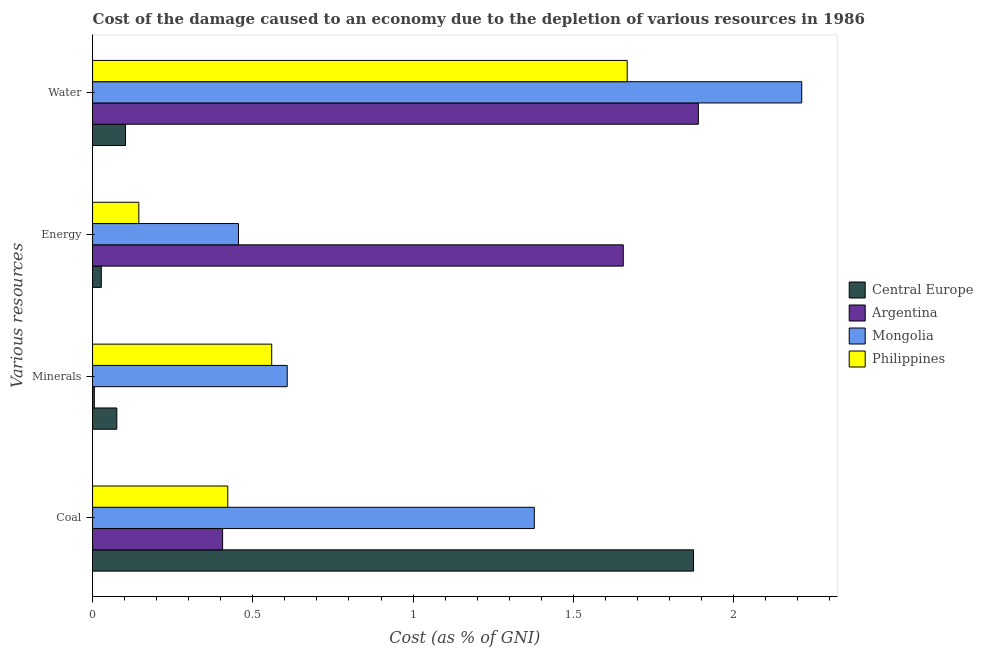How many different coloured bars are there?
Ensure brevity in your answer.  4. Are the number of bars on each tick of the Y-axis equal?
Ensure brevity in your answer.  Yes. What is the label of the 2nd group of bars from the top?
Provide a succinct answer. Energy. What is the cost of damage due to depletion of minerals in Philippines?
Provide a short and direct response. 0.56. Across all countries, what is the maximum cost of damage due to depletion of coal?
Your response must be concise. 1.88. Across all countries, what is the minimum cost of damage due to depletion of water?
Your response must be concise. 0.1. In which country was the cost of damage due to depletion of water maximum?
Your answer should be compact. Mongolia. In which country was the cost of damage due to depletion of coal minimum?
Provide a succinct answer. Argentina. What is the total cost of damage due to depletion of energy in the graph?
Offer a terse response. 2.28. What is the difference between the cost of damage due to depletion of water in Argentina and that in Mongolia?
Keep it short and to the point. -0.32. What is the difference between the cost of damage due to depletion of water in Philippines and the cost of damage due to depletion of coal in Mongolia?
Offer a very short reply. 0.29. What is the average cost of damage due to depletion of minerals per country?
Ensure brevity in your answer.  0.31. What is the difference between the cost of damage due to depletion of minerals and cost of damage due to depletion of energy in Argentina?
Keep it short and to the point. -1.65. What is the ratio of the cost of damage due to depletion of minerals in Philippines to that in Central Europe?
Your answer should be compact. 7.39. What is the difference between the highest and the second highest cost of damage due to depletion of energy?
Offer a very short reply. 1.2. What is the difference between the highest and the lowest cost of damage due to depletion of minerals?
Your answer should be very brief. 0.6. In how many countries, is the cost of damage due to depletion of coal greater than the average cost of damage due to depletion of coal taken over all countries?
Offer a very short reply. 2. Is it the case that in every country, the sum of the cost of damage due to depletion of coal and cost of damage due to depletion of minerals is greater than the sum of cost of damage due to depletion of energy and cost of damage due to depletion of water?
Your response must be concise. No. What does the 1st bar from the top in Water represents?
Give a very brief answer. Philippines. What does the 4th bar from the bottom in Energy represents?
Make the answer very short. Philippines. How many bars are there?
Offer a very short reply. 16. What is the difference between two consecutive major ticks on the X-axis?
Your answer should be very brief. 0.5. Are the values on the major ticks of X-axis written in scientific E-notation?
Keep it short and to the point. No. How many legend labels are there?
Provide a succinct answer. 4. What is the title of the graph?
Provide a succinct answer. Cost of the damage caused to an economy due to the depletion of various resources in 1986 . What is the label or title of the X-axis?
Offer a terse response. Cost (as % of GNI). What is the label or title of the Y-axis?
Provide a succinct answer. Various resources. What is the Cost (as % of GNI) in Central Europe in Coal?
Your answer should be compact. 1.88. What is the Cost (as % of GNI) of Argentina in Coal?
Keep it short and to the point. 0.41. What is the Cost (as % of GNI) of Mongolia in Coal?
Keep it short and to the point. 1.38. What is the Cost (as % of GNI) of Philippines in Coal?
Keep it short and to the point. 0.42. What is the Cost (as % of GNI) in Central Europe in Minerals?
Offer a terse response. 0.08. What is the Cost (as % of GNI) of Argentina in Minerals?
Offer a terse response. 0.01. What is the Cost (as % of GNI) in Mongolia in Minerals?
Keep it short and to the point. 0.61. What is the Cost (as % of GNI) in Philippines in Minerals?
Ensure brevity in your answer.  0.56. What is the Cost (as % of GNI) of Central Europe in Energy?
Ensure brevity in your answer.  0.03. What is the Cost (as % of GNI) in Argentina in Energy?
Keep it short and to the point. 1.66. What is the Cost (as % of GNI) of Mongolia in Energy?
Provide a short and direct response. 0.46. What is the Cost (as % of GNI) of Philippines in Energy?
Give a very brief answer. 0.14. What is the Cost (as % of GNI) of Central Europe in Water?
Keep it short and to the point. 0.1. What is the Cost (as % of GNI) in Argentina in Water?
Provide a short and direct response. 1.89. What is the Cost (as % of GNI) of Mongolia in Water?
Keep it short and to the point. 2.21. What is the Cost (as % of GNI) of Philippines in Water?
Make the answer very short. 1.67. Across all Various resources, what is the maximum Cost (as % of GNI) of Central Europe?
Ensure brevity in your answer.  1.88. Across all Various resources, what is the maximum Cost (as % of GNI) in Argentina?
Offer a terse response. 1.89. Across all Various resources, what is the maximum Cost (as % of GNI) in Mongolia?
Provide a succinct answer. 2.21. Across all Various resources, what is the maximum Cost (as % of GNI) in Philippines?
Your response must be concise. 1.67. Across all Various resources, what is the minimum Cost (as % of GNI) in Central Europe?
Your response must be concise. 0.03. Across all Various resources, what is the minimum Cost (as % of GNI) of Argentina?
Your response must be concise. 0.01. Across all Various resources, what is the minimum Cost (as % of GNI) in Mongolia?
Provide a succinct answer. 0.46. Across all Various resources, what is the minimum Cost (as % of GNI) of Philippines?
Offer a very short reply. 0.14. What is the total Cost (as % of GNI) in Central Europe in the graph?
Make the answer very short. 2.08. What is the total Cost (as % of GNI) in Argentina in the graph?
Provide a short and direct response. 3.96. What is the total Cost (as % of GNI) in Mongolia in the graph?
Provide a short and direct response. 4.65. What is the total Cost (as % of GNI) of Philippines in the graph?
Make the answer very short. 2.79. What is the difference between the Cost (as % of GNI) of Central Europe in Coal and that in Minerals?
Keep it short and to the point. 1.8. What is the difference between the Cost (as % of GNI) of Argentina in Coal and that in Minerals?
Make the answer very short. 0.4. What is the difference between the Cost (as % of GNI) of Mongolia in Coal and that in Minerals?
Offer a very short reply. 0.77. What is the difference between the Cost (as % of GNI) of Philippines in Coal and that in Minerals?
Your answer should be compact. -0.14. What is the difference between the Cost (as % of GNI) of Central Europe in Coal and that in Energy?
Provide a succinct answer. 1.85. What is the difference between the Cost (as % of GNI) of Argentina in Coal and that in Energy?
Your answer should be very brief. -1.25. What is the difference between the Cost (as % of GNI) of Philippines in Coal and that in Energy?
Your response must be concise. 0.28. What is the difference between the Cost (as % of GNI) in Central Europe in Coal and that in Water?
Offer a very short reply. 1.77. What is the difference between the Cost (as % of GNI) in Argentina in Coal and that in Water?
Provide a short and direct response. -1.48. What is the difference between the Cost (as % of GNI) of Mongolia in Coal and that in Water?
Your answer should be very brief. -0.83. What is the difference between the Cost (as % of GNI) of Philippines in Coal and that in Water?
Offer a very short reply. -1.25. What is the difference between the Cost (as % of GNI) of Central Europe in Minerals and that in Energy?
Ensure brevity in your answer.  0.05. What is the difference between the Cost (as % of GNI) in Argentina in Minerals and that in Energy?
Provide a succinct answer. -1.65. What is the difference between the Cost (as % of GNI) of Mongolia in Minerals and that in Energy?
Provide a succinct answer. 0.15. What is the difference between the Cost (as % of GNI) in Philippines in Minerals and that in Energy?
Keep it short and to the point. 0.41. What is the difference between the Cost (as % of GNI) in Central Europe in Minerals and that in Water?
Your answer should be compact. -0.03. What is the difference between the Cost (as % of GNI) of Argentina in Minerals and that in Water?
Make the answer very short. -1.88. What is the difference between the Cost (as % of GNI) in Mongolia in Minerals and that in Water?
Your answer should be compact. -1.61. What is the difference between the Cost (as % of GNI) in Philippines in Minerals and that in Water?
Make the answer very short. -1.11. What is the difference between the Cost (as % of GNI) in Central Europe in Energy and that in Water?
Offer a terse response. -0.08. What is the difference between the Cost (as % of GNI) in Argentina in Energy and that in Water?
Give a very brief answer. -0.23. What is the difference between the Cost (as % of GNI) of Mongolia in Energy and that in Water?
Your response must be concise. -1.76. What is the difference between the Cost (as % of GNI) in Philippines in Energy and that in Water?
Give a very brief answer. -1.52. What is the difference between the Cost (as % of GNI) in Central Europe in Coal and the Cost (as % of GNI) in Argentina in Minerals?
Offer a very short reply. 1.87. What is the difference between the Cost (as % of GNI) in Central Europe in Coal and the Cost (as % of GNI) in Mongolia in Minerals?
Give a very brief answer. 1.27. What is the difference between the Cost (as % of GNI) of Central Europe in Coal and the Cost (as % of GNI) of Philippines in Minerals?
Offer a very short reply. 1.32. What is the difference between the Cost (as % of GNI) of Argentina in Coal and the Cost (as % of GNI) of Mongolia in Minerals?
Keep it short and to the point. -0.2. What is the difference between the Cost (as % of GNI) of Argentina in Coal and the Cost (as % of GNI) of Philippines in Minerals?
Your answer should be compact. -0.15. What is the difference between the Cost (as % of GNI) in Mongolia in Coal and the Cost (as % of GNI) in Philippines in Minerals?
Keep it short and to the point. 0.82. What is the difference between the Cost (as % of GNI) in Central Europe in Coal and the Cost (as % of GNI) in Argentina in Energy?
Give a very brief answer. 0.22. What is the difference between the Cost (as % of GNI) of Central Europe in Coal and the Cost (as % of GNI) of Mongolia in Energy?
Make the answer very short. 1.42. What is the difference between the Cost (as % of GNI) of Central Europe in Coal and the Cost (as % of GNI) of Philippines in Energy?
Give a very brief answer. 1.73. What is the difference between the Cost (as % of GNI) of Argentina in Coal and the Cost (as % of GNI) of Mongolia in Energy?
Your answer should be very brief. -0.05. What is the difference between the Cost (as % of GNI) of Argentina in Coal and the Cost (as % of GNI) of Philippines in Energy?
Ensure brevity in your answer.  0.26. What is the difference between the Cost (as % of GNI) in Mongolia in Coal and the Cost (as % of GNI) in Philippines in Energy?
Keep it short and to the point. 1.23. What is the difference between the Cost (as % of GNI) of Central Europe in Coal and the Cost (as % of GNI) of Argentina in Water?
Provide a short and direct response. -0.01. What is the difference between the Cost (as % of GNI) of Central Europe in Coal and the Cost (as % of GNI) of Mongolia in Water?
Keep it short and to the point. -0.34. What is the difference between the Cost (as % of GNI) of Central Europe in Coal and the Cost (as % of GNI) of Philippines in Water?
Give a very brief answer. 0.21. What is the difference between the Cost (as % of GNI) in Argentina in Coal and the Cost (as % of GNI) in Mongolia in Water?
Offer a terse response. -1.81. What is the difference between the Cost (as % of GNI) in Argentina in Coal and the Cost (as % of GNI) in Philippines in Water?
Your answer should be compact. -1.26. What is the difference between the Cost (as % of GNI) in Mongolia in Coal and the Cost (as % of GNI) in Philippines in Water?
Provide a succinct answer. -0.29. What is the difference between the Cost (as % of GNI) in Central Europe in Minerals and the Cost (as % of GNI) in Argentina in Energy?
Offer a terse response. -1.58. What is the difference between the Cost (as % of GNI) of Central Europe in Minerals and the Cost (as % of GNI) of Mongolia in Energy?
Provide a succinct answer. -0.38. What is the difference between the Cost (as % of GNI) in Central Europe in Minerals and the Cost (as % of GNI) in Philippines in Energy?
Make the answer very short. -0.07. What is the difference between the Cost (as % of GNI) in Argentina in Minerals and the Cost (as % of GNI) in Mongolia in Energy?
Offer a very short reply. -0.45. What is the difference between the Cost (as % of GNI) of Argentina in Minerals and the Cost (as % of GNI) of Philippines in Energy?
Offer a terse response. -0.14. What is the difference between the Cost (as % of GNI) in Mongolia in Minerals and the Cost (as % of GNI) in Philippines in Energy?
Make the answer very short. 0.46. What is the difference between the Cost (as % of GNI) in Central Europe in Minerals and the Cost (as % of GNI) in Argentina in Water?
Your answer should be very brief. -1.81. What is the difference between the Cost (as % of GNI) in Central Europe in Minerals and the Cost (as % of GNI) in Mongolia in Water?
Provide a short and direct response. -2.14. What is the difference between the Cost (as % of GNI) in Central Europe in Minerals and the Cost (as % of GNI) in Philippines in Water?
Offer a very short reply. -1.59. What is the difference between the Cost (as % of GNI) of Argentina in Minerals and the Cost (as % of GNI) of Mongolia in Water?
Ensure brevity in your answer.  -2.21. What is the difference between the Cost (as % of GNI) in Argentina in Minerals and the Cost (as % of GNI) in Philippines in Water?
Your response must be concise. -1.66. What is the difference between the Cost (as % of GNI) of Mongolia in Minerals and the Cost (as % of GNI) of Philippines in Water?
Ensure brevity in your answer.  -1.06. What is the difference between the Cost (as % of GNI) of Central Europe in Energy and the Cost (as % of GNI) of Argentina in Water?
Offer a very short reply. -1.86. What is the difference between the Cost (as % of GNI) in Central Europe in Energy and the Cost (as % of GNI) in Mongolia in Water?
Make the answer very short. -2.19. What is the difference between the Cost (as % of GNI) in Central Europe in Energy and the Cost (as % of GNI) in Philippines in Water?
Provide a succinct answer. -1.64. What is the difference between the Cost (as % of GNI) in Argentina in Energy and the Cost (as % of GNI) in Mongolia in Water?
Provide a succinct answer. -0.56. What is the difference between the Cost (as % of GNI) in Argentina in Energy and the Cost (as % of GNI) in Philippines in Water?
Your answer should be compact. -0.01. What is the difference between the Cost (as % of GNI) of Mongolia in Energy and the Cost (as % of GNI) of Philippines in Water?
Provide a short and direct response. -1.21. What is the average Cost (as % of GNI) of Central Europe per Various resources?
Provide a short and direct response. 0.52. What is the average Cost (as % of GNI) of Argentina per Various resources?
Keep it short and to the point. 0.99. What is the average Cost (as % of GNI) in Mongolia per Various resources?
Offer a very short reply. 1.16. What is the average Cost (as % of GNI) in Philippines per Various resources?
Provide a short and direct response. 0.7. What is the difference between the Cost (as % of GNI) of Central Europe and Cost (as % of GNI) of Argentina in Coal?
Your answer should be compact. 1.47. What is the difference between the Cost (as % of GNI) of Central Europe and Cost (as % of GNI) of Mongolia in Coal?
Provide a short and direct response. 0.5. What is the difference between the Cost (as % of GNI) of Central Europe and Cost (as % of GNI) of Philippines in Coal?
Provide a short and direct response. 1.45. What is the difference between the Cost (as % of GNI) in Argentina and Cost (as % of GNI) in Mongolia in Coal?
Give a very brief answer. -0.97. What is the difference between the Cost (as % of GNI) in Argentina and Cost (as % of GNI) in Philippines in Coal?
Provide a succinct answer. -0.02. What is the difference between the Cost (as % of GNI) in Mongolia and Cost (as % of GNI) in Philippines in Coal?
Make the answer very short. 0.96. What is the difference between the Cost (as % of GNI) of Central Europe and Cost (as % of GNI) of Argentina in Minerals?
Keep it short and to the point. 0.07. What is the difference between the Cost (as % of GNI) in Central Europe and Cost (as % of GNI) in Mongolia in Minerals?
Offer a terse response. -0.53. What is the difference between the Cost (as % of GNI) of Central Europe and Cost (as % of GNI) of Philippines in Minerals?
Your response must be concise. -0.48. What is the difference between the Cost (as % of GNI) in Argentina and Cost (as % of GNI) in Mongolia in Minerals?
Your answer should be compact. -0.6. What is the difference between the Cost (as % of GNI) in Argentina and Cost (as % of GNI) in Philippines in Minerals?
Offer a terse response. -0.55. What is the difference between the Cost (as % of GNI) in Mongolia and Cost (as % of GNI) in Philippines in Minerals?
Make the answer very short. 0.05. What is the difference between the Cost (as % of GNI) in Central Europe and Cost (as % of GNI) in Argentina in Energy?
Offer a very short reply. -1.63. What is the difference between the Cost (as % of GNI) of Central Europe and Cost (as % of GNI) of Mongolia in Energy?
Your response must be concise. -0.43. What is the difference between the Cost (as % of GNI) in Central Europe and Cost (as % of GNI) in Philippines in Energy?
Offer a very short reply. -0.12. What is the difference between the Cost (as % of GNI) of Argentina and Cost (as % of GNI) of Mongolia in Energy?
Keep it short and to the point. 1.2. What is the difference between the Cost (as % of GNI) of Argentina and Cost (as % of GNI) of Philippines in Energy?
Keep it short and to the point. 1.51. What is the difference between the Cost (as % of GNI) in Mongolia and Cost (as % of GNI) in Philippines in Energy?
Provide a succinct answer. 0.31. What is the difference between the Cost (as % of GNI) of Central Europe and Cost (as % of GNI) of Argentina in Water?
Give a very brief answer. -1.79. What is the difference between the Cost (as % of GNI) in Central Europe and Cost (as % of GNI) in Mongolia in Water?
Give a very brief answer. -2.11. What is the difference between the Cost (as % of GNI) of Central Europe and Cost (as % of GNI) of Philippines in Water?
Ensure brevity in your answer.  -1.57. What is the difference between the Cost (as % of GNI) in Argentina and Cost (as % of GNI) in Mongolia in Water?
Your response must be concise. -0.32. What is the difference between the Cost (as % of GNI) of Argentina and Cost (as % of GNI) of Philippines in Water?
Offer a very short reply. 0.22. What is the difference between the Cost (as % of GNI) of Mongolia and Cost (as % of GNI) of Philippines in Water?
Your answer should be compact. 0.54. What is the ratio of the Cost (as % of GNI) of Central Europe in Coal to that in Minerals?
Give a very brief answer. 24.79. What is the ratio of the Cost (as % of GNI) of Argentina in Coal to that in Minerals?
Your answer should be very brief. 73.12. What is the ratio of the Cost (as % of GNI) in Mongolia in Coal to that in Minerals?
Your answer should be very brief. 2.27. What is the ratio of the Cost (as % of GNI) in Philippines in Coal to that in Minerals?
Your answer should be very brief. 0.75. What is the ratio of the Cost (as % of GNI) in Central Europe in Coal to that in Energy?
Your response must be concise. 68.76. What is the ratio of the Cost (as % of GNI) in Argentina in Coal to that in Energy?
Offer a terse response. 0.24. What is the ratio of the Cost (as % of GNI) in Mongolia in Coal to that in Energy?
Ensure brevity in your answer.  3.03. What is the ratio of the Cost (as % of GNI) of Philippines in Coal to that in Energy?
Make the answer very short. 2.92. What is the ratio of the Cost (as % of GNI) in Central Europe in Coal to that in Water?
Provide a short and direct response. 18.22. What is the ratio of the Cost (as % of GNI) in Argentina in Coal to that in Water?
Offer a terse response. 0.21. What is the ratio of the Cost (as % of GNI) of Mongolia in Coal to that in Water?
Offer a terse response. 0.62. What is the ratio of the Cost (as % of GNI) of Philippines in Coal to that in Water?
Your answer should be very brief. 0.25. What is the ratio of the Cost (as % of GNI) of Central Europe in Minerals to that in Energy?
Keep it short and to the point. 2.77. What is the ratio of the Cost (as % of GNI) in Argentina in Minerals to that in Energy?
Your answer should be compact. 0. What is the ratio of the Cost (as % of GNI) in Mongolia in Minerals to that in Energy?
Give a very brief answer. 1.33. What is the ratio of the Cost (as % of GNI) of Philippines in Minerals to that in Energy?
Provide a short and direct response. 3.87. What is the ratio of the Cost (as % of GNI) of Central Europe in Minerals to that in Water?
Your response must be concise. 0.73. What is the ratio of the Cost (as % of GNI) of Argentina in Minerals to that in Water?
Your response must be concise. 0. What is the ratio of the Cost (as % of GNI) of Mongolia in Minerals to that in Water?
Provide a succinct answer. 0.27. What is the ratio of the Cost (as % of GNI) of Philippines in Minerals to that in Water?
Your answer should be compact. 0.34. What is the ratio of the Cost (as % of GNI) in Central Europe in Energy to that in Water?
Your answer should be very brief. 0.27. What is the ratio of the Cost (as % of GNI) in Argentina in Energy to that in Water?
Give a very brief answer. 0.88. What is the ratio of the Cost (as % of GNI) in Mongolia in Energy to that in Water?
Make the answer very short. 0.21. What is the ratio of the Cost (as % of GNI) of Philippines in Energy to that in Water?
Give a very brief answer. 0.09. What is the difference between the highest and the second highest Cost (as % of GNI) of Central Europe?
Your answer should be compact. 1.77. What is the difference between the highest and the second highest Cost (as % of GNI) in Argentina?
Your response must be concise. 0.23. What is the difference between the highest and the second highest Cost (as % of GNI) in Mongolia?
Make the answer very short. 0.83. What is the difference between the highest and the second highest Cost (as % of GNI) in Philippines?
Your answer should be very brief. 1.11. What is the difference between the highest and the lowest Cost (as % of GNI) in Central Europe?
Your answer should be very brief. 1.85. What is the difference between the highest and the lowest Cost (as % of GNI) of Argentina?
Ensure brevity in your answer.  1.88. What is the difference between the highest and the lowest Cost (as % of GNI) in Mongolia?
Your answer should be compact. 1.76. What is the difference between the highest and the lowest Cost (as % of GNI) in Philippines?
Your answer should be compact. 1.52. 